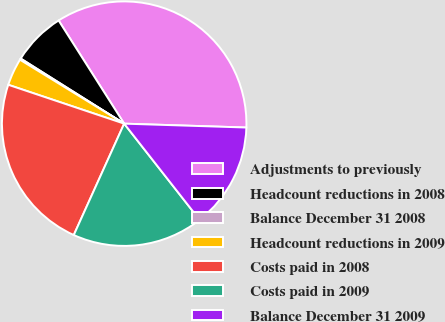Convert chart to OTSL. <chart><loc_0><loc_0><loc_500><loc_500><pie_chart><fcel>Adjustments to previously<fcel>Headcount reductions in 2008<fcel>Balance December 31 2008<fcel>Headcount reductions in 2009<fcel>Costs paid in 2008<fcel>Costs paid in 2009<fcel>Balance December 31 2009<nl><fcel>34.52%<fcel>7.05%<fcel>0.18%<fcel>3.61%<fcel>23.39%<fcel>17.35%<fcel>13.91%<nl></chart> 